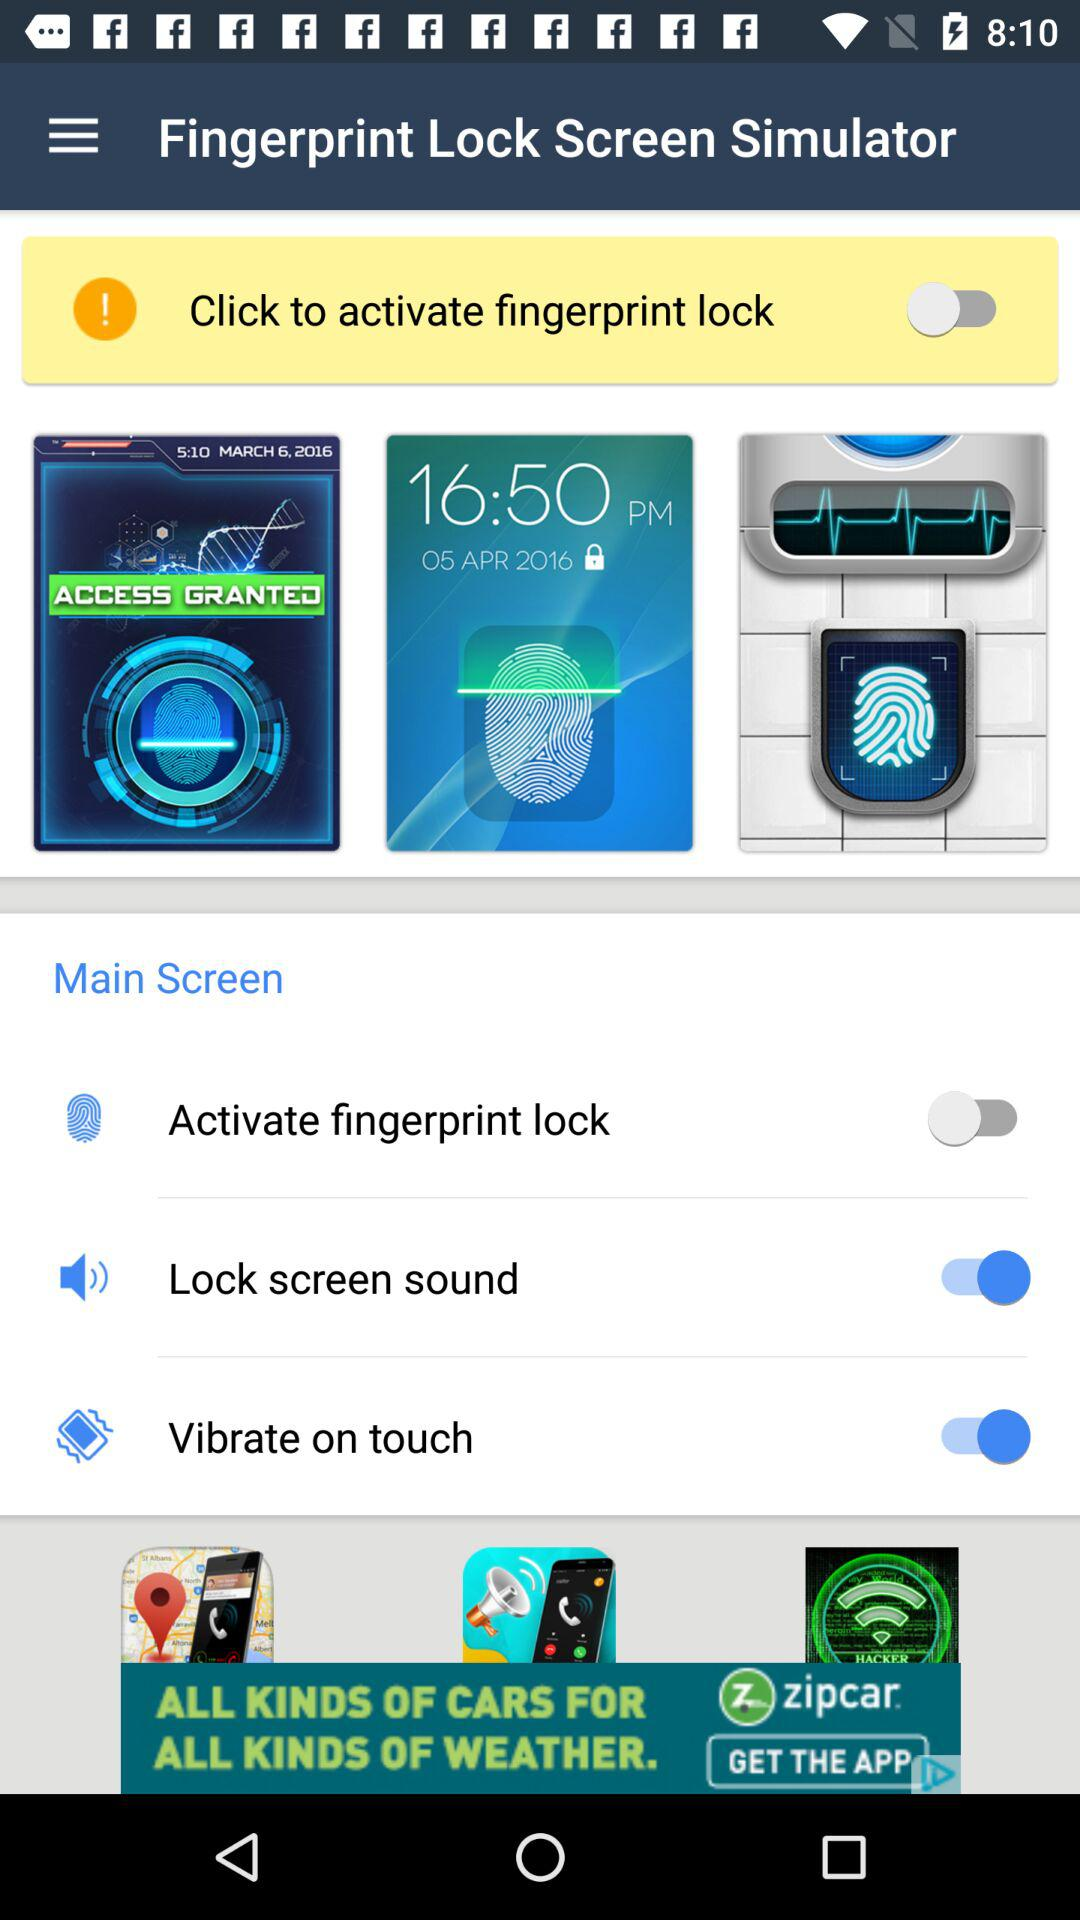Which fingerprint is registered in the application?
When the provided information is insufficient, respond with <no answer>. <no answer> 